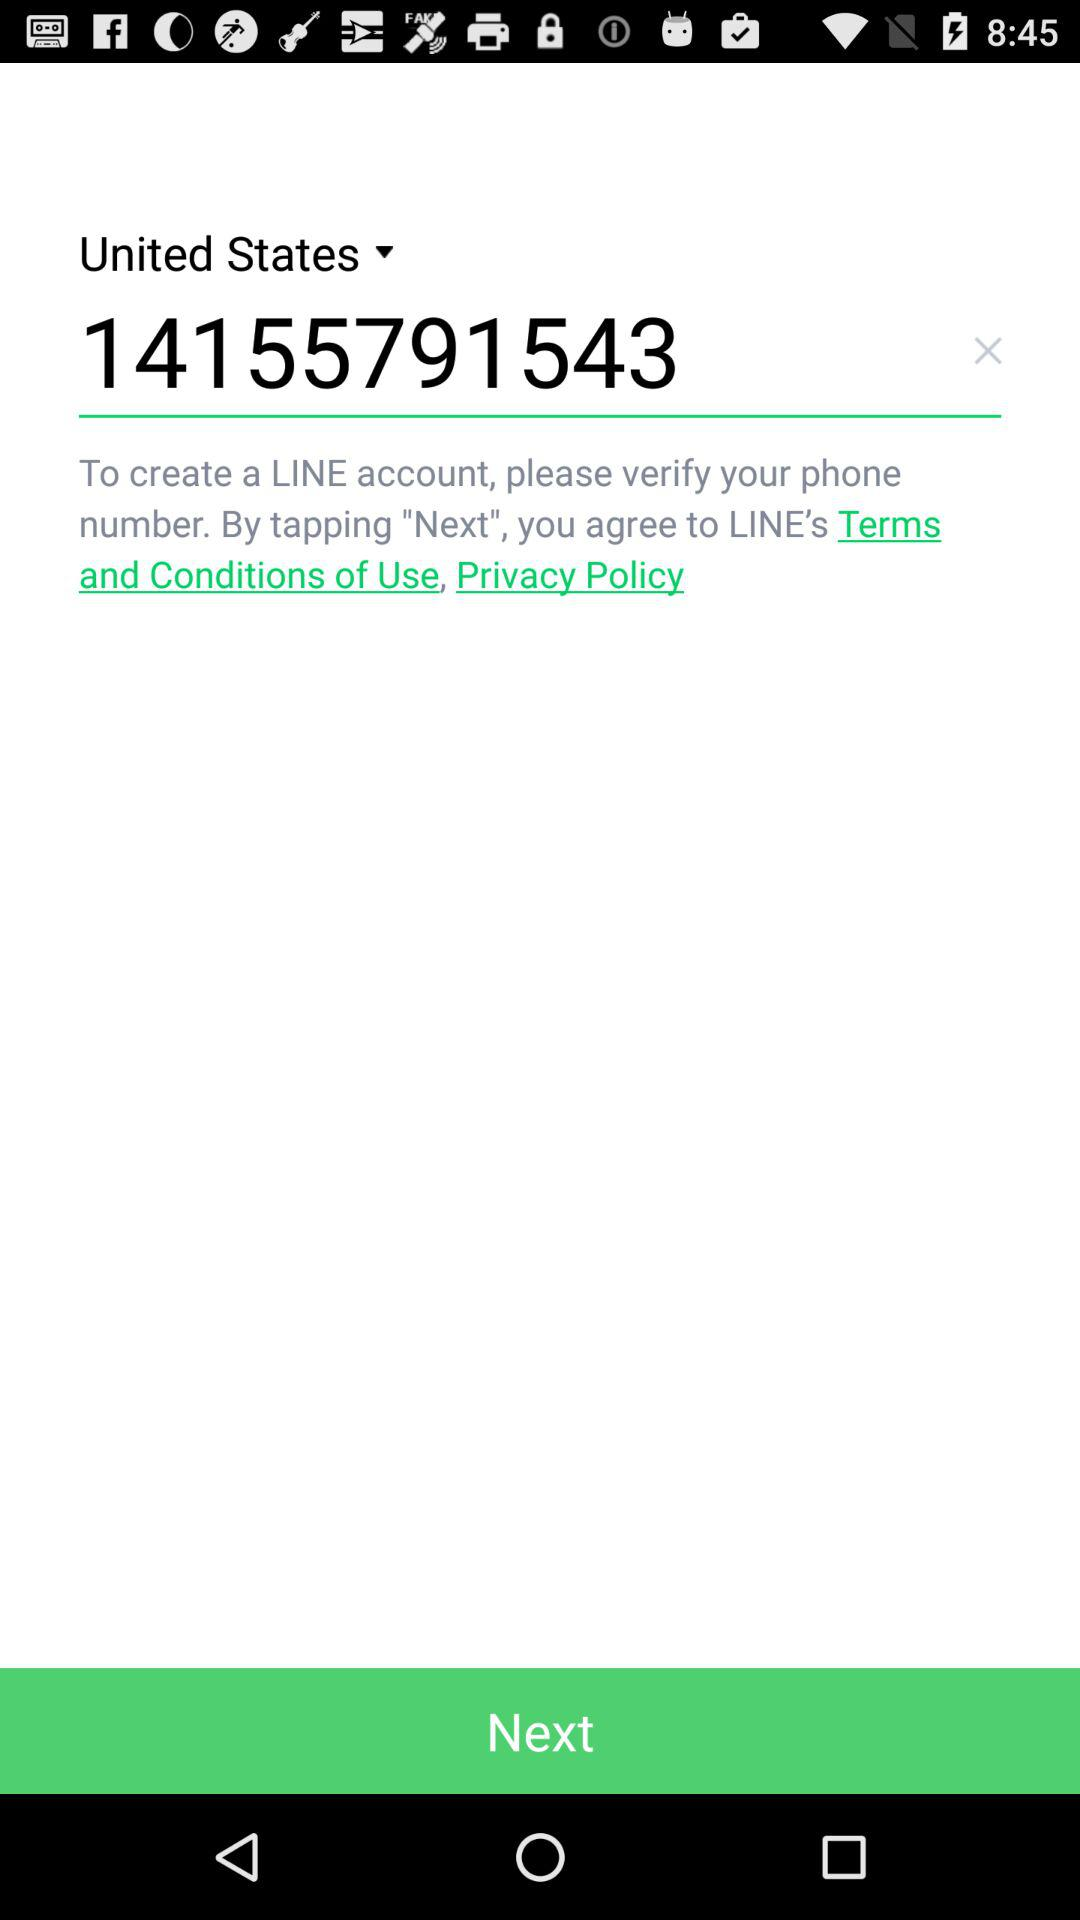What is the entered phone number? The entered phone number is 14155791543. 